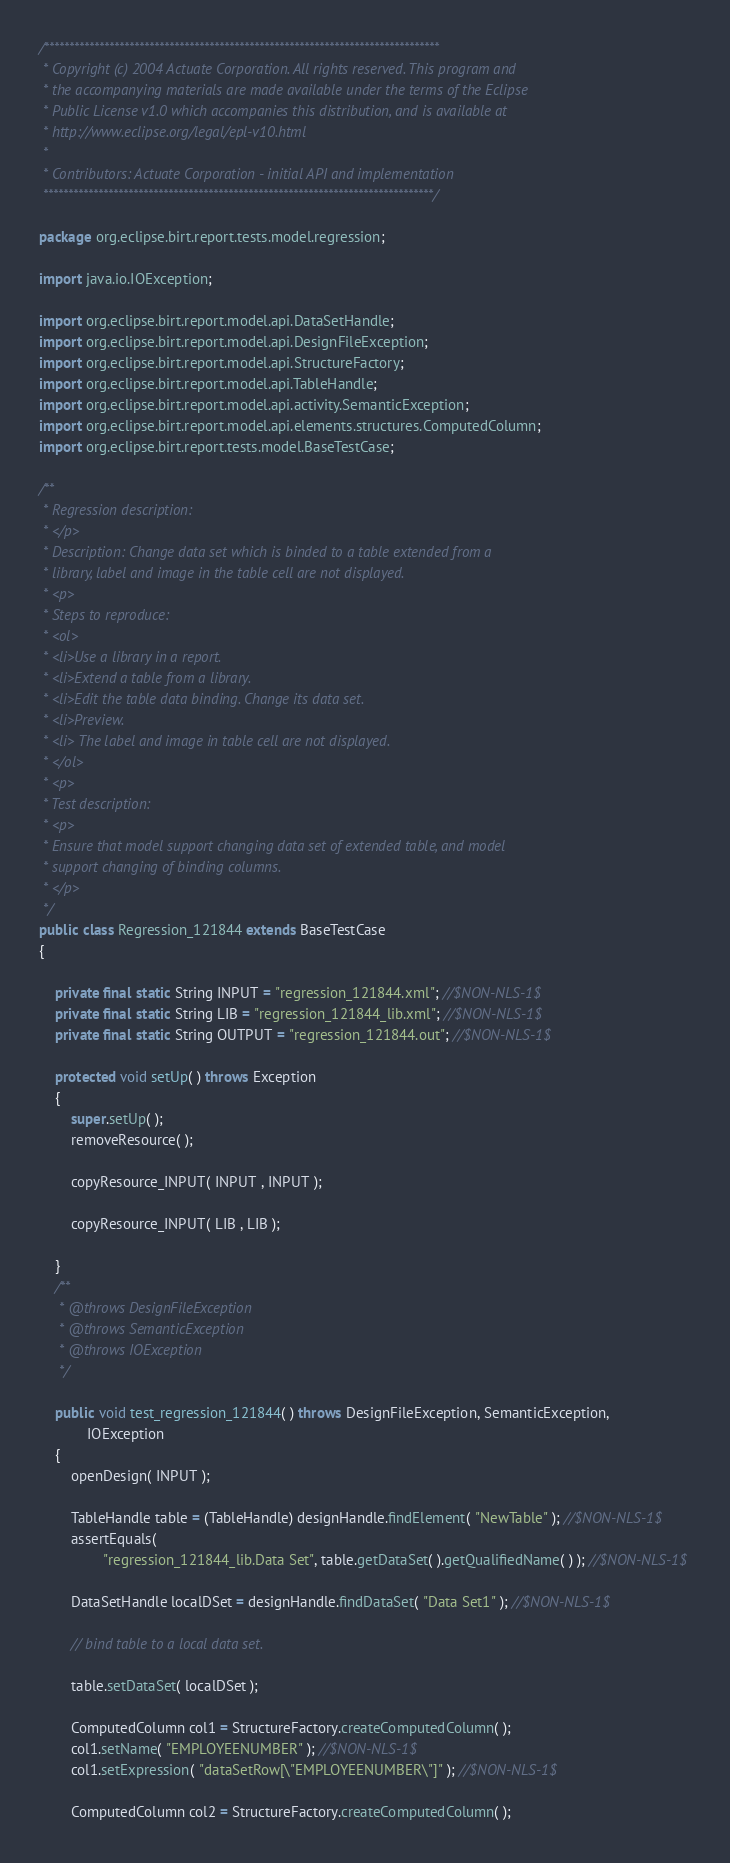<code> <loc_0><loc_0><loc_500><loc_500><_Java_>/*******************************************************************************
 * Copyright (c) 2004 Actuate Corporation. All rights reserved. This program and
 * the accompanying materials are made available under the terms of the Eclipse
 * Public License v1.0 which accompanies this distribution, and is available at
 * http://www.eclipse.org/legal/epl-v10.html
 * 
 * Contributors: Actuate Corporation - initial API and implementation
 ******************************************************************************/

package org.eclipse.birt.report.tests.model.regression;

import java.io.IOException;

import org.eclipse.birt.report.model.api.DataSetHandle;
import org.eclipse.birt.report.model.api.DesignFileException;
import org.eclipse.birt.report.model.api.StructureFactory;
import org.eclipse.birt.report.model.api.TableHandle;
import org.eclipse.birt.report.model.api.activity.SemanticException;
import org.eclipse.birt.report.model.api.elements.structures.ComputedColumn;
import org.eclipse.birt.report.tests.model.BaseTestCase;

/**
 * Regression description:
 * </p>
 * Description: Change data set which is binded to a table extended from a
 * library, label and image in the table cell are not displayed.
 * <p>
 * Steps to reproduce:
 * <ol>
 * <li>Use a library in a report.
 * <li>Extend a table from a library.
 * <li>Edit the table data binding. Change its data set.
 * <li>Preview.
 * <li> The label and image in table cell are not displayed.
 * </ol>
 * <p>
 * Test description:
 * <p>
 * Ensure that model support changing data set of extended table, and model
 * support changing of binding columns.
 * </p>
 */
public class Regression_121844 extends BaseTestCase
{

	private final static String INPUT = "regression_121844.xml"; //$NON-NLS-1$
	private final static String LIB = "regression_121844_lib.xml"; //$NON-NLS-1$
	private final static String OUTPUT = "regression_121844.out"; //$NON-NLS-1$

	protected void setUp( ) throws Exception
	{
		super.setUp( );
		removeResource( );
		
		copyResource_INPUT( INPUT , INPUT );
		
		copyResource_INPUT( LIB , LIB );
		
	}
	/**
	 * @throws DesignFileException
	 * @throws SemanticException
	 * @throws IOException
	 */

	public void test_regression_121844( ) throws DesignFileException, SemanticException,
			IOException
	{
		openDesign( INPUT );

		TableHandle table = (TableHandle) designHandle.findElement( "NewTable" ); //$NON-NLS-1$
		assertEquals(
				"regression_121844_lib.Data Set", table.getDataSet( ).getQualifiedName( ) ); //$NON-NLS-1$

		DataSetHandle localDSet = designHandle.findDataSet( "Data Set1" ); //$NON-NLS-1$

		// bind table to a local data set.

		table.setDataSet( localDSet );

		ComputedColumn col1 = StructureFactory.createComputedColumn( );
		col1.setName( "EMPLOYEENUMBER" ); //$NON-NLS-1$
		col1.setExpression( "dataSetRow[\"EMPLOYEENUMBER\"]" ); //$NON-NLS-1$

		ComputedColumn col2 = StructureFactory.createComputedColumn( );</code> 